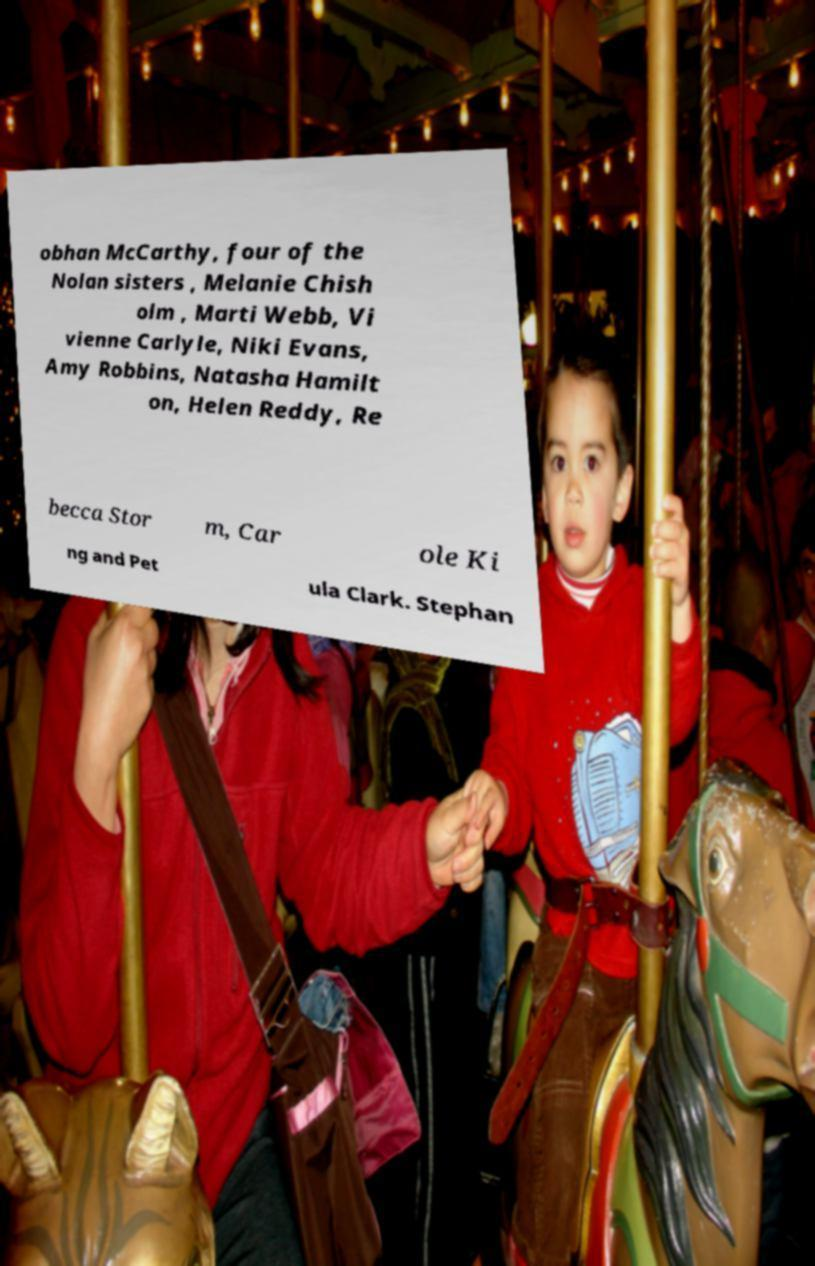Can you read and provide the text displayed in the image?This photo seems to have some interesting text. Can you extract and type it out for me? obhan McCarthy, four of the Nolan sisters , Melanie Chish olm , Marti Webb, Vi vienne Carlyle, Niki Evans, Amy Robbins, Natasha Hamilt on, Helen Reddy, Re becca Stor m, Car ole Ki ng and Pet ula Clark. Stephan 